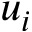Convert formula to latex. <formula><loc_0><loc_0><loc_500><loc_500>u _ { i }</formula> 